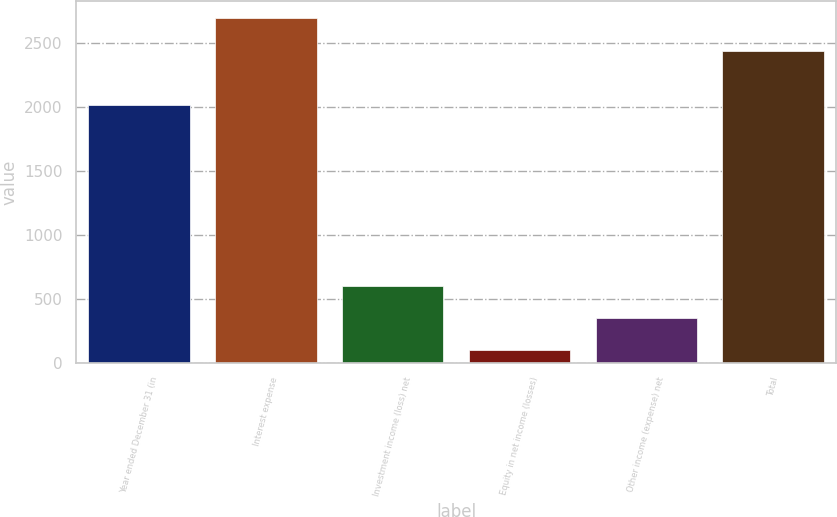Convert chart. <chart><loc_0><loc_0><loc_500><loc_500><bar_chart><fcel>Year ended December 31 (in<fcel>Interest expense<fcel>Investment income (loss) net<fcel>Equity in net income (losses)<fcel>Other income (expense) net<fcel>Total<nl><fcel>2014<fcel>2691<fcel>601<fcel>97<fcel>349<fcel>2439<nl></chart> 